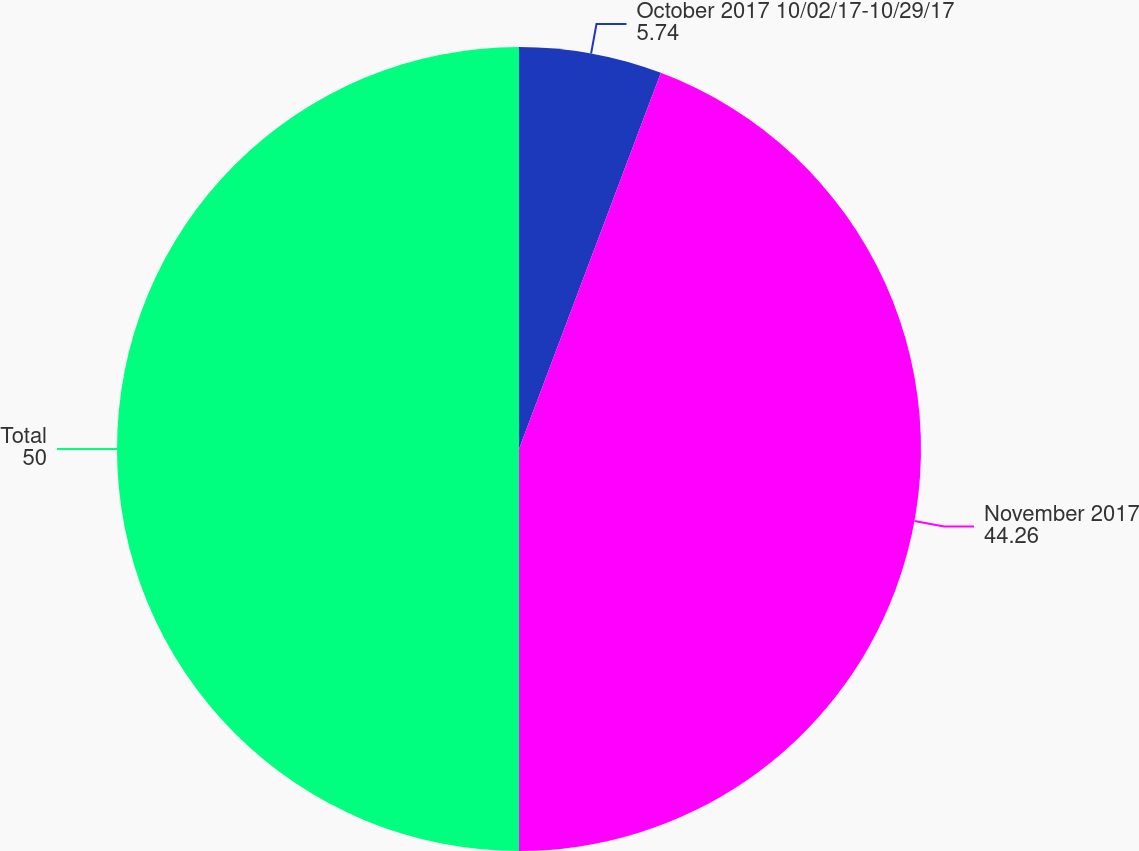Convert chart. <chart><loc_0><loc_0><loc_500><loc_500><pie_chart><fcel>October 2017 10/02/17-10/29/17<fcel>November 2017<fcel>Total<nl><fcel>5.74%<fcel>44.26%<fcel>50.0%<nl></chart> 